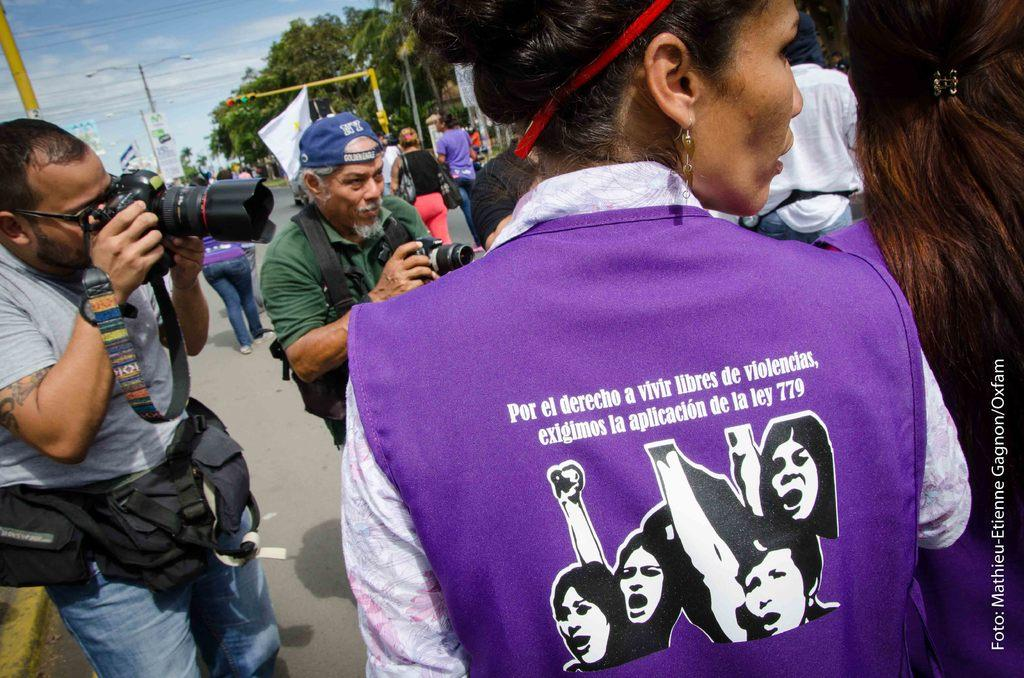How many people are holding cameras in the image? There are 2 people holding cameras in the image. What are the 2 people doing with the cameras? The 2 people are looking at someone while holding cameras. What can be seen on the road in the image? There are many other people on the road in the image. What type of vegetation is present around the road in the image? Trees are present around the road in the image. What is the color of the sky in the image? The sky is blue in the image. What type of bait is being used to attract the animal in the image? There is no bait or animal present in the image. How much payment is being exchanged between the people in the image? There is no indication of any payment being exchanged between the people in the image. 